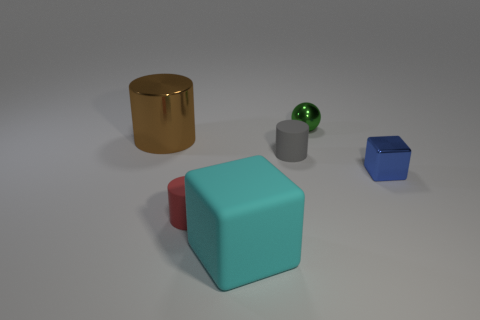Add 1 blue objects. How many objects exist? 7 Subtract all balls. How many objects are left? 5 Add 3 gray rubber cylinders. How many gray rubber cylinders are left? 4 Add 1 gray cylinders. How many gray cylinders exist? 2 Subtract 0 purple cylinders. How many objects are left? 6 Subtract all blue metal things. Subtract all rubber things. How many objects are left? 2 